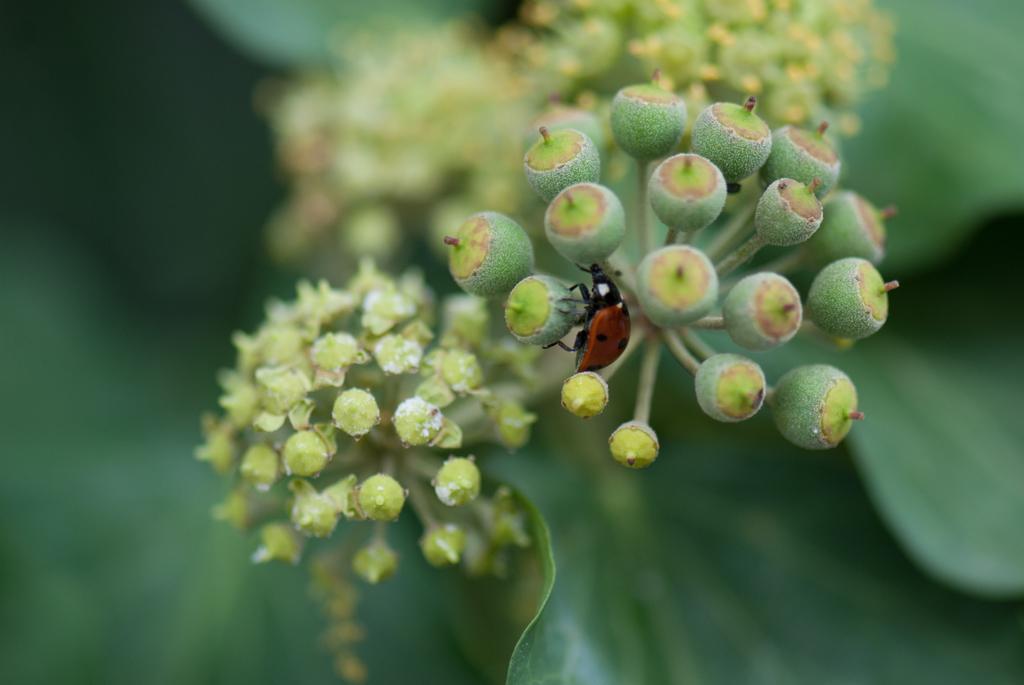Can you describe this image briefly? In this image I can see few buds and insect on it. The insect is in red and black color. Background is blurred. 